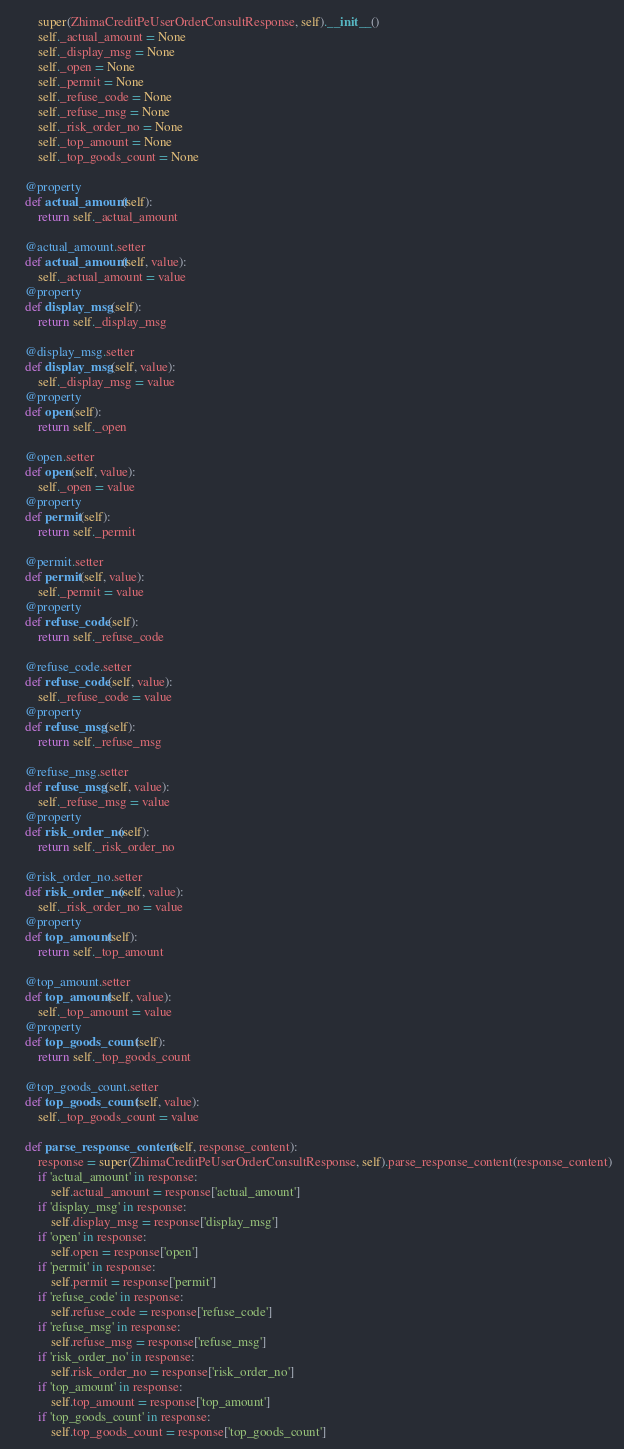Convert code to text. <code><loc_0><loc_0><loc_500><loc_500><_Python_>        super(ZhimaCreditPeUserOrderConsultResponse, self).__init__()
        self._actual_amount = None
        self._display_msg = None
        self._open = None
        self._permit = None
        self._refuse_code = None
        self._refuse_msg = None
        self._risk_order_no = None
        self._top_amount = None
        self._top_goods_count = None

    @property
    def actual_amount(self):
        return self._actual_amount

    @actual_amount.setter
    def actual_amount(self, value):
        self._actual_amount = value
    @property
    def display_msg(self):
        return self._display_msg

    @display_msg.setter
    def display_msg(self, value):
        self._display_msg = value
    @property
    def open(self):
        return self._open

    @open.setter
    def open(self, value):
        self._open = value
    @property
    def permit(self):
        return self._permit

    @permit.setter
    def permit(self, value):
        self._permit = value
    @property
    def refuse_code(self):
        return self._refuse_code

    @refuse_code.setter
    def refuse_code(self, value):
        self._refuse_code = value
    @property
    def refuse_msg(self):
        return self._refuse_msg

    @refuse_msg.setter
    def refuse_msg(self, value):
        self._refuse_msg = value
    @property
    def risk_order_no(self):
        return self._risk_order_no

    @risk_order_no.setter
    def risk_order_no(self, value):
        self._risk_order_no = value
    @property
    def top_amount(self):
        return self._top_amount

    @top_amount.setter
    def top_amount(self, value):
        self._top_amount = value
    @property
    def top_goods_count(self):
        return self._top_goods_count

    @top_goods_count.setter
    def top_goods_count(self, value):
        self._top_goods_count = value

    def parse_response_content(self, response_content):
        response = super(ZhimaCreditPeUserOrderConsultResponse, self).parse_response_content(response_content)
        if 'actual_amount' in response:
            self.actual_amount = response['actual_amount']
        if 'display_msg' in response:
            self.display_msg = response['display_msg']
        if 'open' in response:
            self.open = response['open']
        if 'permit' in response:
            self.permit = response['permit']
        if 'refuse_code' in response:
            self.refuse_code = response['refuse_code']
        if 'refuse_msg' in response:
            self.refuse_msg = response['refuse_msg']
        if 'risk_order_no' in response:
            self.risk_order_no = response['risk_order_no']
        if 'top_amount' in response:
            self.top_amount = response['top_amount']
        if 'top_goods_count' in response:
            self.top_goods_count = response['top_goods_count']
</code> 